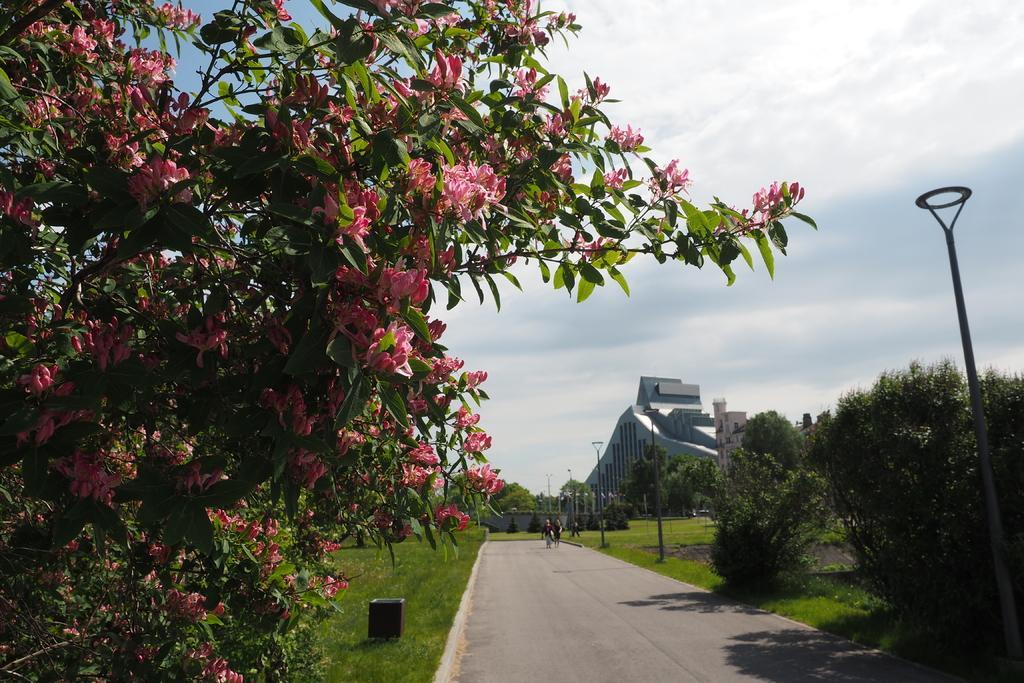Describe this image in one or two sentences. In the center of the image we can see trees, persons, building, flowers, road, poles, sky and clouds. 